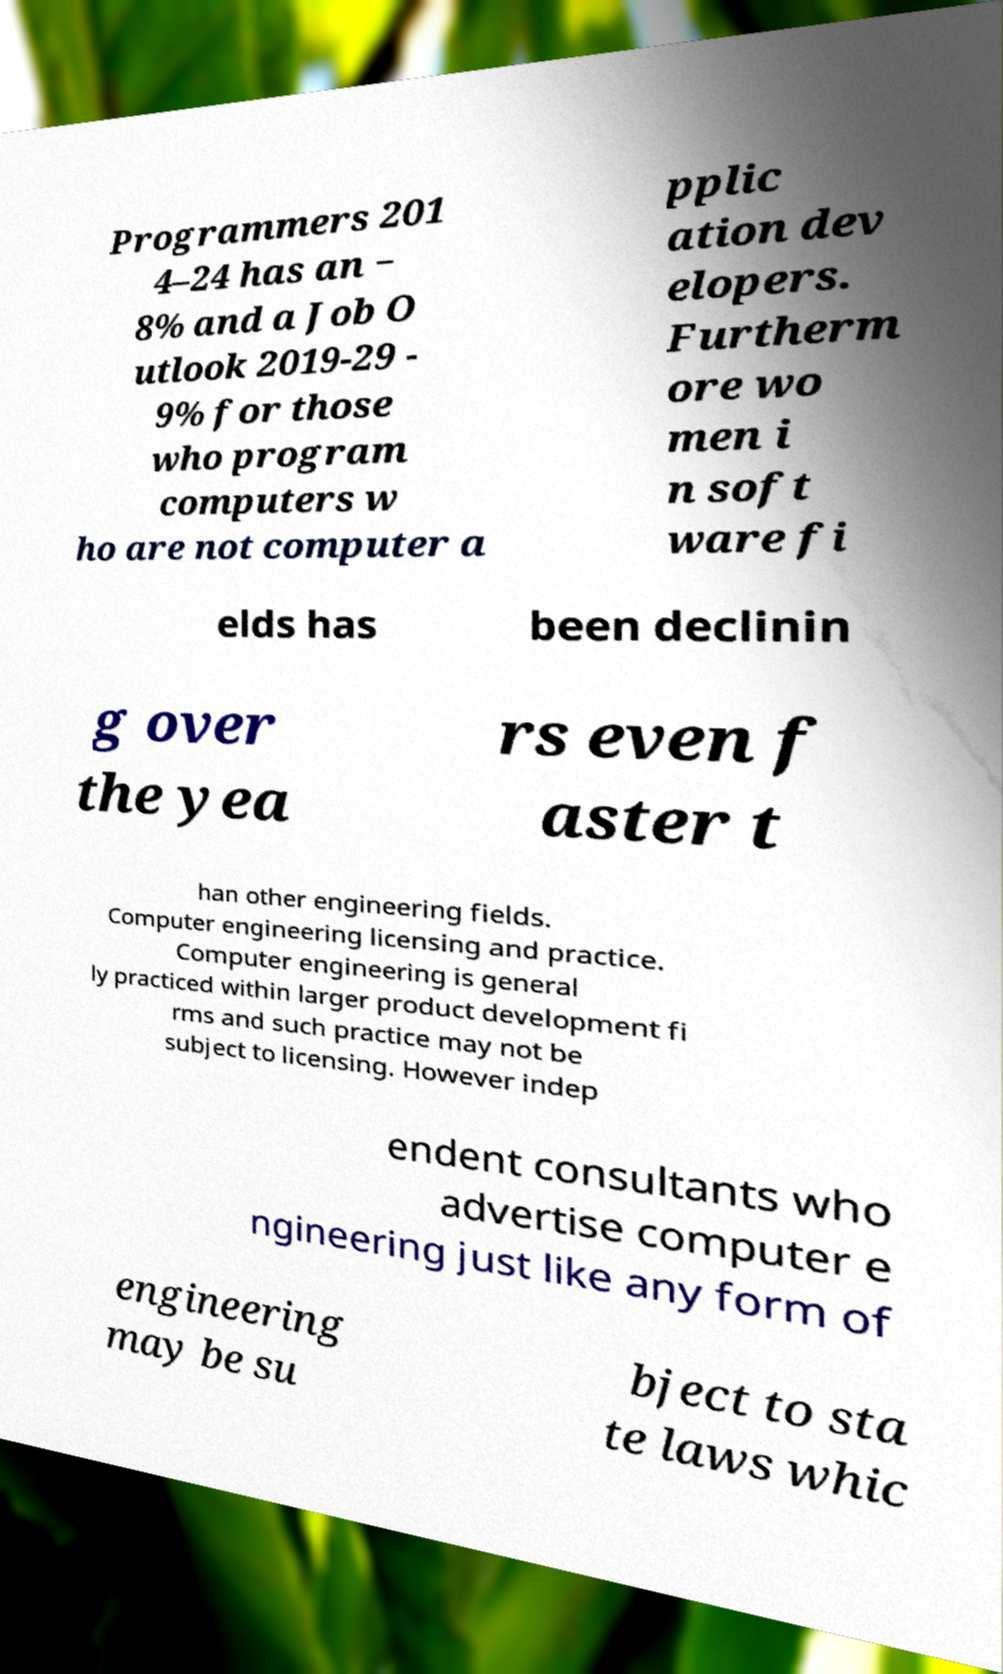For documentation purposes, I need the text within this image transcribed. Could you provide that? Programmers 201 4–24 has an − 8% and a Job O utlook 2019-29 - 9% for those who program computers w ho are not computer a pplic ation dev elopers. Furtherm ore wo men i n soft ware fi elds has been declinin g over the yea rs even f aster t han other engineering fields. Computer engineering licensing and practice. Computer engineering is general ly practiced within larger product development fi rms and such practice may not be subject to licensing. However indep endent consultants who advertise computer e ngineering just like any form of engineering may be su bject to sta te laws whic 